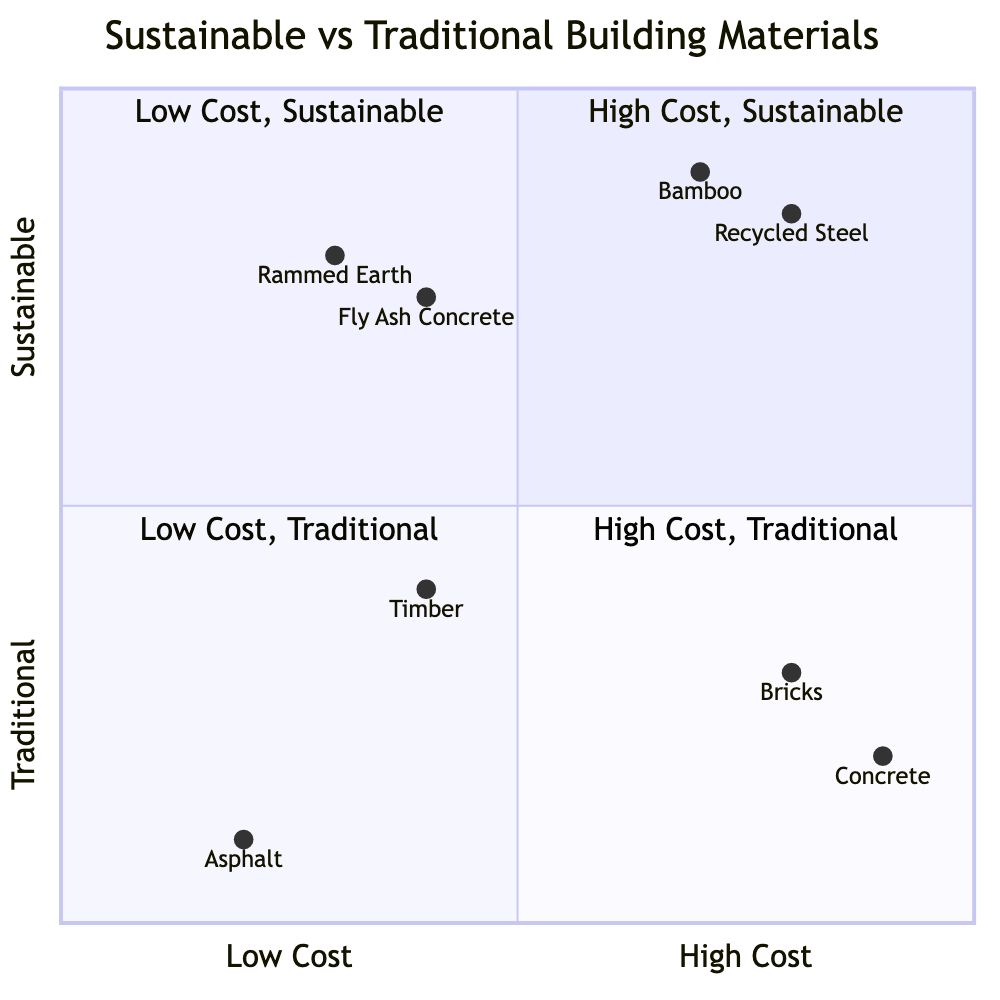What materials fall under high cost and sustainable? In the quadrant chart, the materials categorized as 'High Cost' and 'Sustainable' include 'Bamboo' and 'Recycled Steel.' These materials are positioned in quadrant 1, specifically indicating their relationship to sustainability and cost.
Answer: Bamboo, Recycled Steel Which traditional material is the most cost-effective? Looking at the quadrant chart, 'Asphalt' is positioned in quadrant 3 under 'Low Cost' and 'Traditional,' making it the most cost-effective traditional material among the options provided.
Answer: Asphalt How many sustainable materials are categorized as low cost? From the quadrant chart, 'Rammed Earth' and 'Fly Ash Concrete' are both noted in the 'Low Cost' and 'Sustainable' section of quadrant 2. Thus, there are two sustainable materials categorized as low cost.
Answer: 2 Which traditional material contributes significantly to CO2 emissions? Examining the quadrant chart, 'Concrete' is mentioned in quadrant 4 under 'High Cost' and 'Traditional,' with a note that it contributes significantly to CO2 emissions. This specifically identifies it among traditional materials.
Answer: Concrete What is the cost nature of 'Timber'? 'Timber' appears in quadrant 3, categorized under 'Low Cost' and 'Traditional.' This shows that 'Timber' is considered relatively affordable among traditional materials.
Answer: Low Cost Which sustainable material has high costs due to its recycling process? 'Recycled Steel' is noted in the 'High Costs' and 'Sustainable' section of quadrant 1 and is recognized specifically for its expense due to the recycling process.
Answer: Recycled Steel What factor defines 'Fly Ash Concrete'? In the quadrant chart, 'Fly Ash Concrete,' which is positioned in quadrant 2 under 'Low Cost' and 'Sustainable,' is defined by utilizing industrial waste, which helps to reduce both costs and environmental impact. This clearly depicts its sustainable nature.
Answer: Utilizes industrial waste Which material has high energy consumption in its production? The 'Bricks' material appears in quadrant 4 under 'High Cost' and 'Traditional,' indicating its production method that involves high energy consumption. This highlights a critical environmental concern associated with traditional construction materials.
Answer: Bricks 